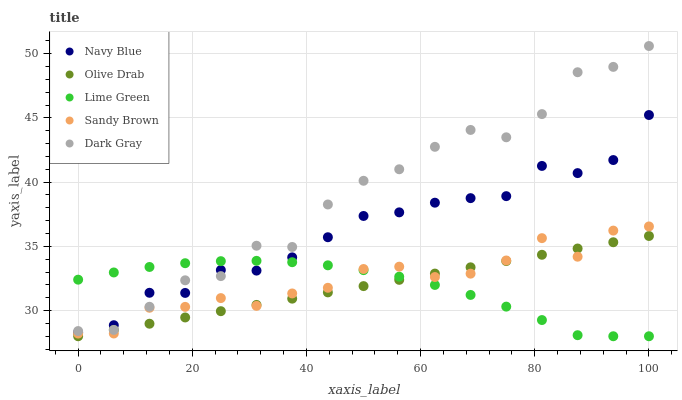Does Lime Green have the minimum area under the curve?
Answer yes or no. Yes. Does Dark Gray have the maximum area under the curve?
Answer yes or no. Yes. Does Navy Blue have the minimum area under the curve?
Answer yes or no. No. Does Navy Blue have the maximum area under the curve?
Answer yes or no. No. Is Olive Drab the smoothest?
Answer yes or no. Yes. Is Dark Gray the roughest?
Answer yes or no. Yes. Is Navy Blue the smoothest?
Answer yes or no. No. Is Navy Blue the roughest?
Answer yes or no. No. Does Lime Green have the lowest value?
Answer yes or no. Yes. Does Navy Blue have the lowest value?
Answer yes or no. No. Does Dark Gray have the highest value?
Answer yes or no. Yes. Does Navy Blue have the highest value?
Answer yes or no. No. Is Sandy Brown less than Navy Blue?
Answer yes or no. Yes. Is Dark Gray greater than Sandy Brown?
Answer yes or no. Yes. Does Navy Blue intersect Dark Gray?
Answer yes or no. Yes. Is Navy Blue less than Dark Gray?
Answer yes or no. No. Is Navy Blue greater than Dark Gray?
Answer yes or no. No. Does Sandy Brown intersect Navy Blue?
Answer yes or no. No. 